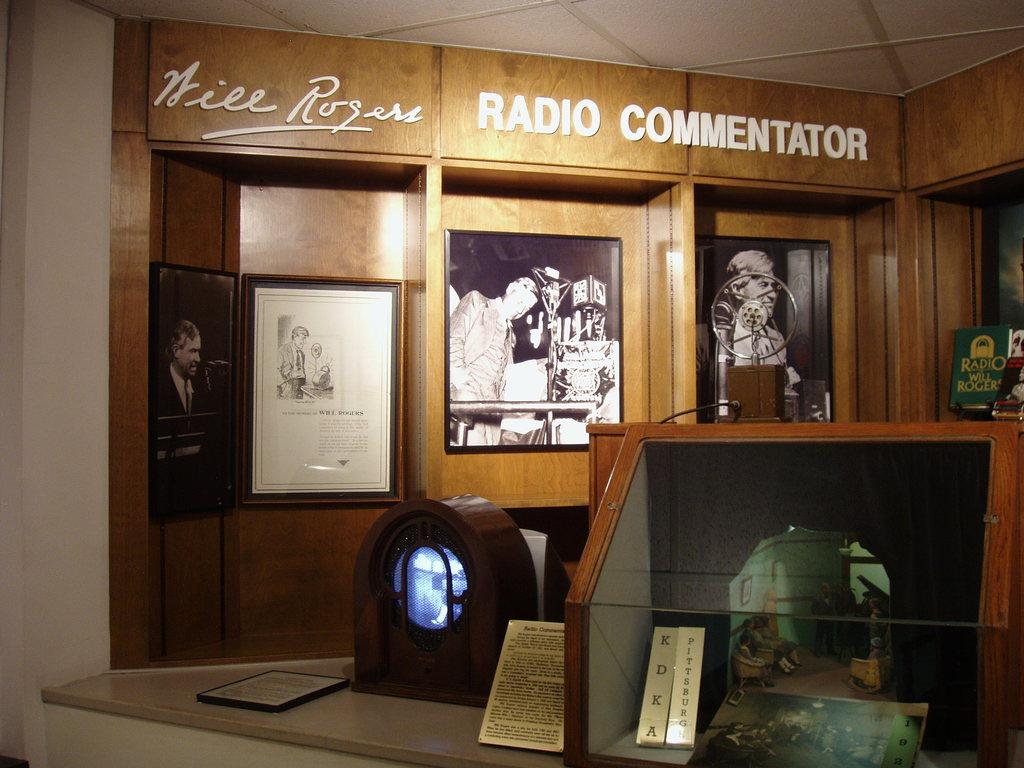What is the name on the top left?
Your response must be concise. Will rogers. 